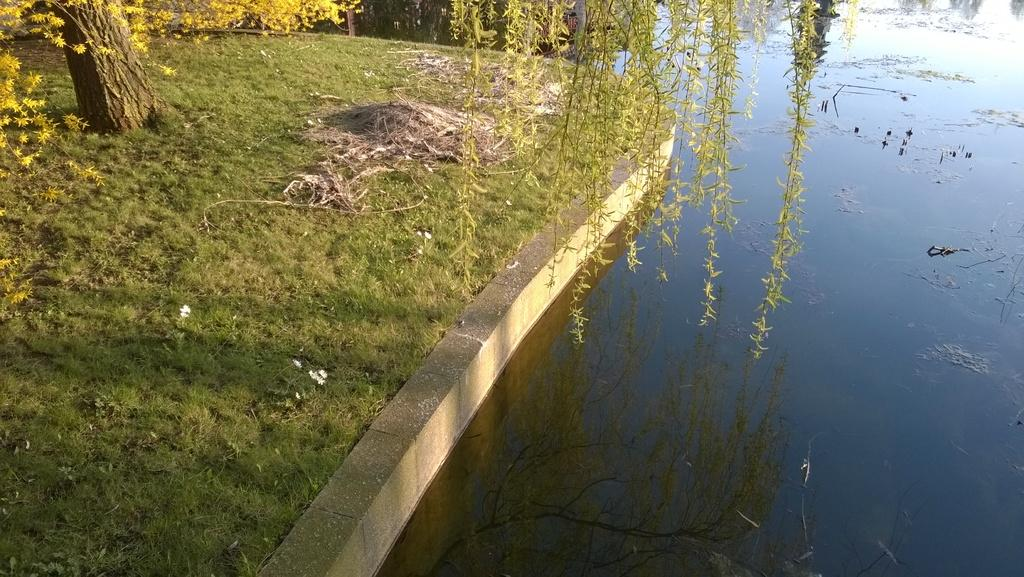What is the primary element present in the image? There is water in the image. What type of vegetation can be seen in the image? There is dried grass, green grass, leaves, and stems in the image. Can you describe the tree in the image? There is a tree in the image. What is the name of the thrill ride featured in the image? There is no thrill ride present in the image; it features water, vegetation, and a tree. 